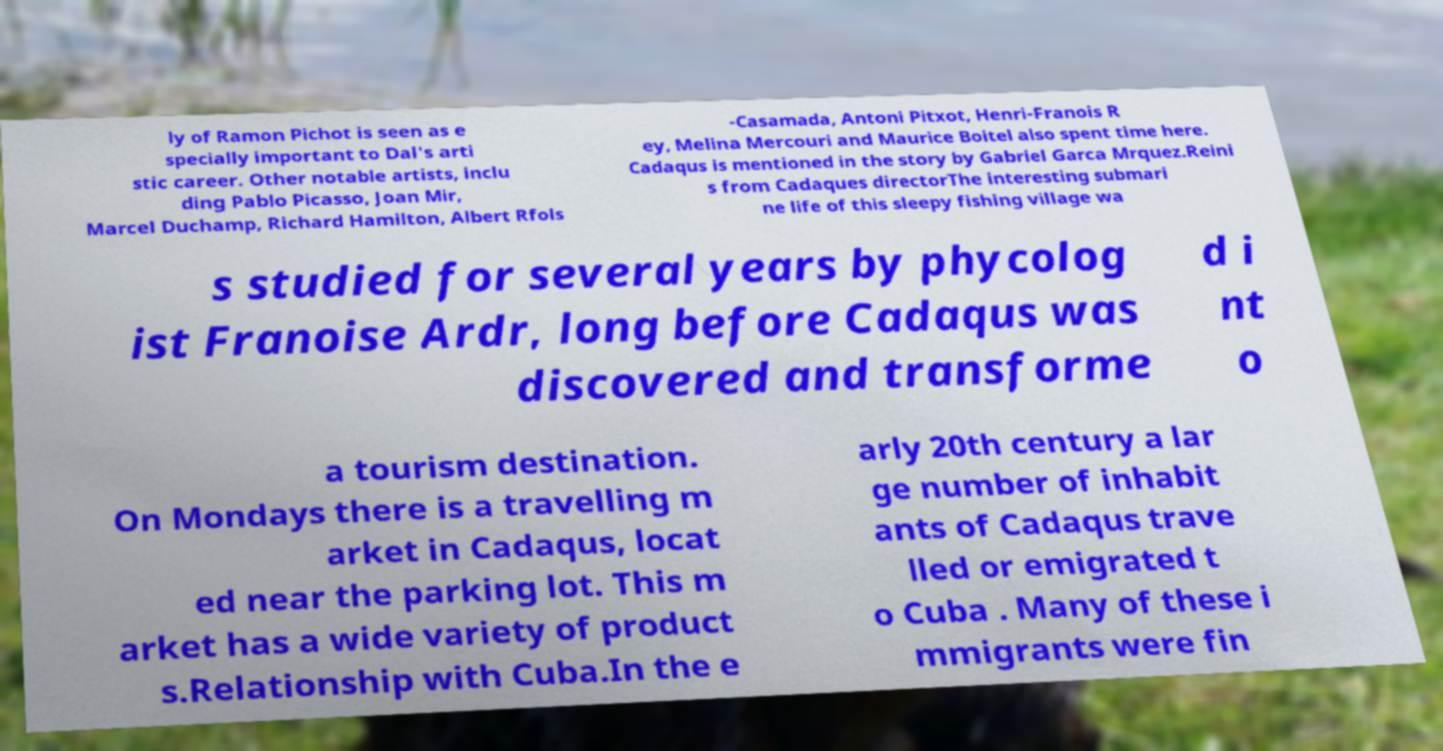Could you assist in decoding the text presented in this image and type it out clearly? ly of Ramon Pichot is seen as e specially important to Dal's arti stic career. Other notable artists, inclu ding Pablo Picasso, Joan Mir, Marcel Duchamp, Richard Hamilton, Albert Rfols -Casamada, Antoni Pitxot, Henri-Franois R ey, Melina Mercouri and Maurice Boitel also spent time here. Cadaqus is mentioned in the story by Gabriel Garca Mrquez.Reini s from Cadaques directorThe interesting submari ne life of this sleepy fishing village wa s studied for several years by phycolog ist Franoise Ardr, long before Cadaqus was discovered and transforme d i nt o a tourism destination. On Mondays there is a travelling m arket in Cadaqus, locat ed near the parking lot. This m arket has a wide variety of product s.Relationship with Cuba.In the e arly 20th century a lar ge number of inhabit ants of Cadaqus trave lled or emigrated t o Cuba . Many of these i mmigrants were fin 